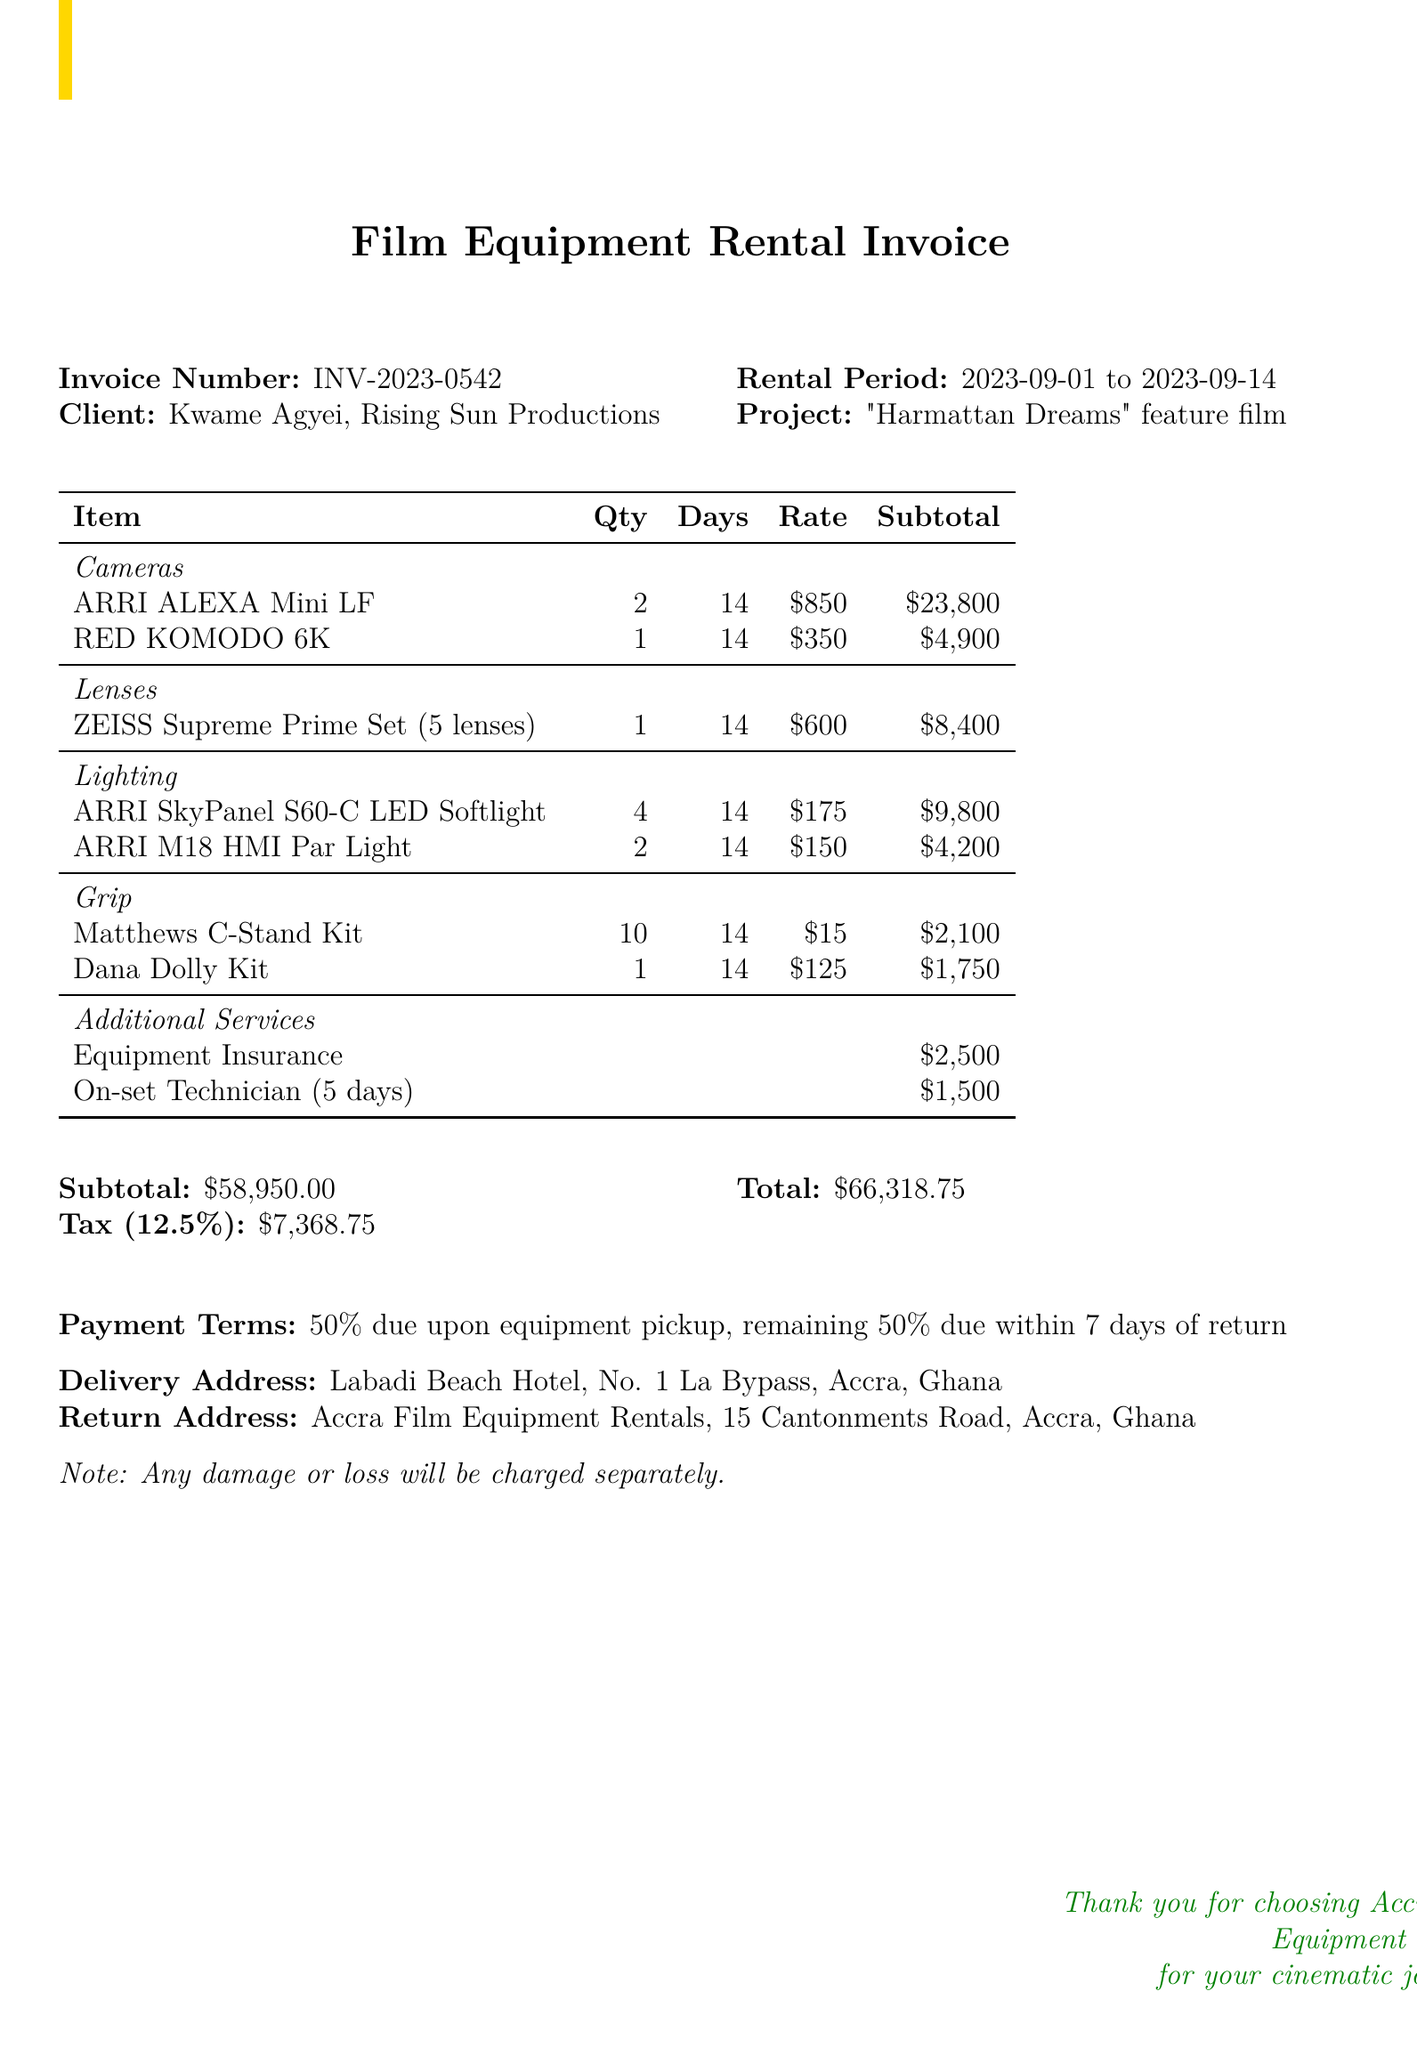what is the invoice number? The invoice number is specified in the document as a unique identifier for the rental transaction.
Answer: INV-2023-0542 who is the client? The client name is clearly mentioned in the document, representing the individual or entity renting the equipment.
Answer: Kwame Agyei what is the rental period? The rental period indicates the start and end dates for which the equipment is rented, providing essential time frame information.
Answer: 2023-09-01 to 2023-09-14 how many ARRI ALEXA Mini LF cameras were rented? The quantity of ARRI ALEXA Mini LF cameras is detailed in the equipment section of the document.
Answer: 2 what is the subtotal amount of the equipment rental? The subtotal summarizes the total cost of the rented equipment before tax and additional services.
Answer: $58950 what percentage is the tax rate? The document lists the tax information, specifically the percentage applied to the subtotal.
Answer: 12.5% how much does the equipment insurance cost? The cost of equipment insurance is explicitly mentioned in the additional services section, representing an optional added expense.
Answer: $2500 what are the payment terms? The payment terms specify the conditions under which payment should be made, detailing the timing of the payment.
Answer: 50% due upon equipment pickup, remaining 50% due within 7 days of return where is the delivery address? The delivery address is provided in the document to indicate where the rented equipment should be delivered.
Answer: Labadi Beach Hotel, No. 1 La Bypass, Accra, Ghana 